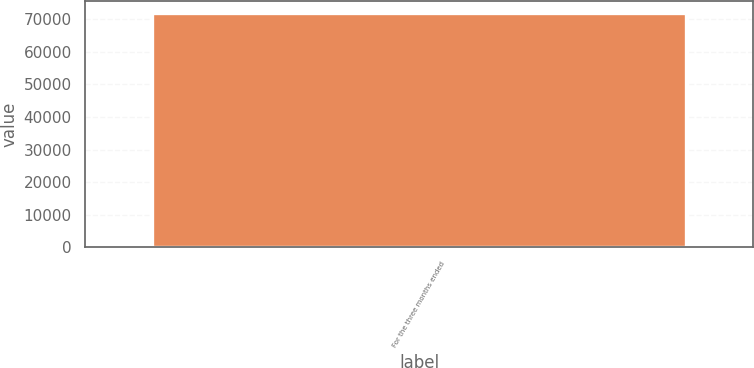Convert chart to OTSL. <chart><loc_0><loc_0><loc_500><loc_500><bar_chart><fcel>For the three months ended<nl><fcel>72022<nl></chart> 